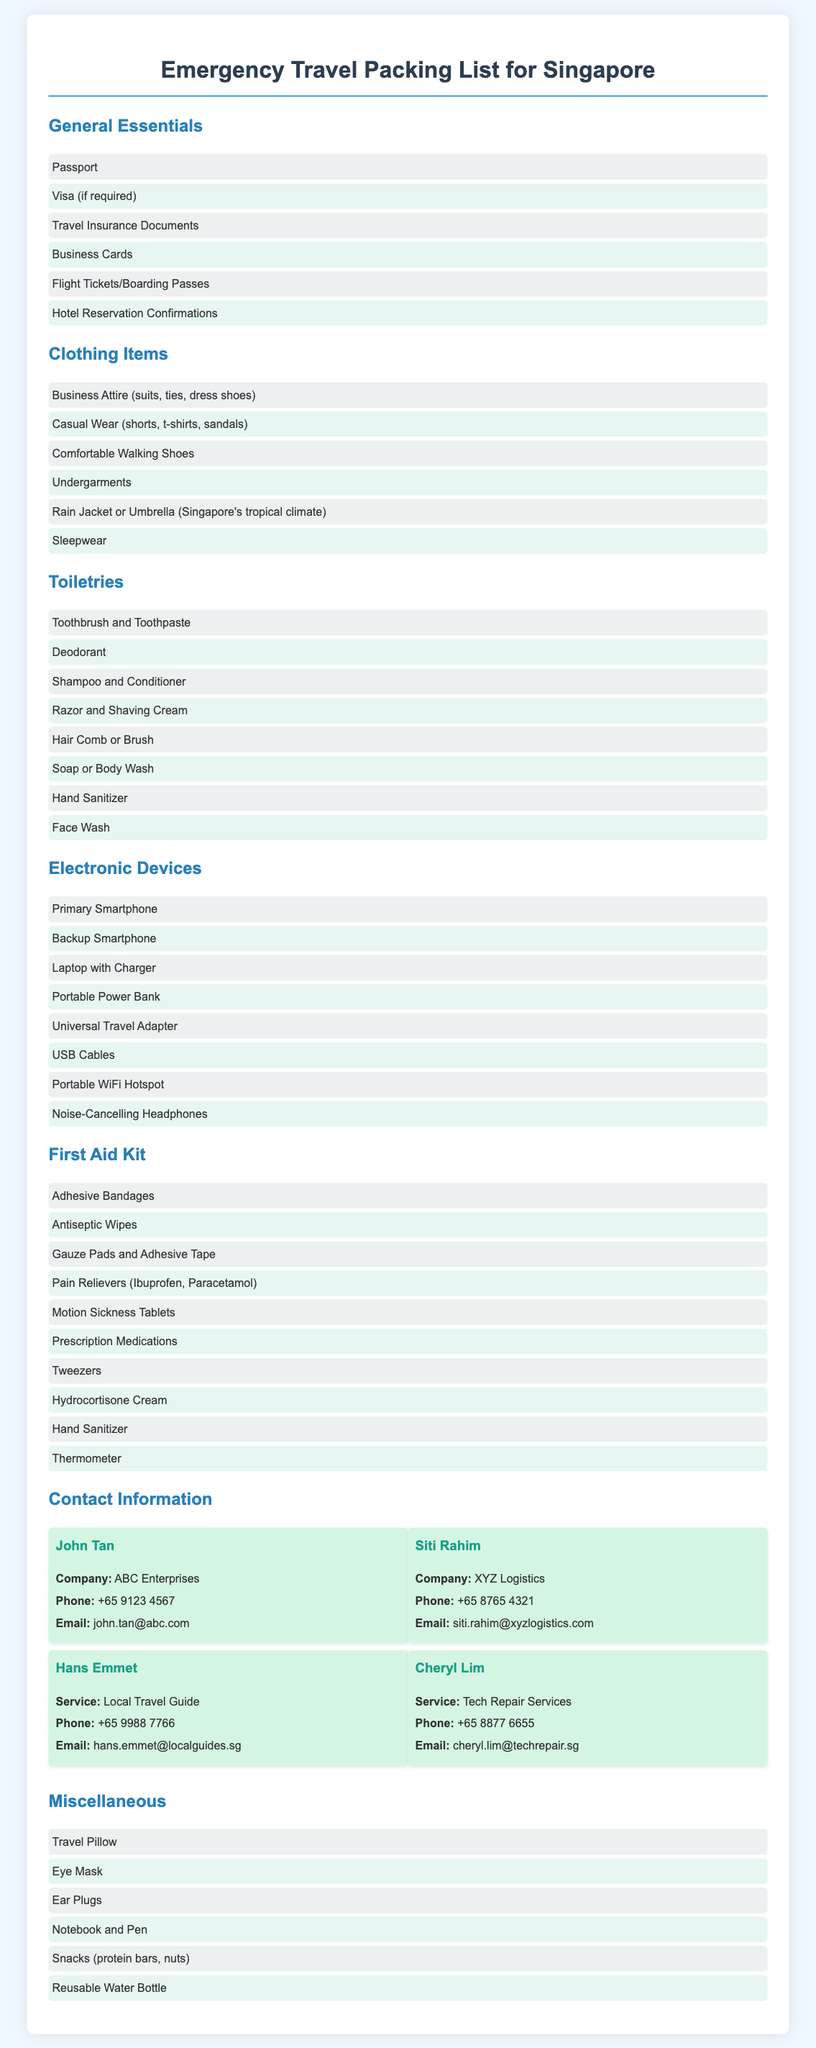what should I pack in my First Aid Kit? The document lists specific items that should be included in the First Aid Kit, such as Adhesive Bandages and Pain Relievers.
Answer: Adhesive Bandages, Antiseptic Wipes, Gauze Pads, Pain Relievers, Motion Sickness Tablets, Prescription Medications, Tweezers, Hydrocortisone Cream, Hand Sanitizer, Thermometer how many Contact Information entries are provided? The document contains four contact information entries for individuals and service providers.
Answer: 4 what type of clothing items should I bring? The document specifies various clothing categories including Business Attire and Casual Wear for the trip.
Answer: Business Attire, Casual Wear, Comfortable Walking Shoes, Undergarments, Rain Jacket, Sleepwear who is the contact for Local Travel Guide? The contact information includes a name associated with the service of a local travel guide.
Answer: Hans Emmet which electronic devices should I ensure to have? The list of electronic devices includes primary and backup devices, a laptop, and a portable power bank among others.
Answer: Primary Smartphone, Backup Smartphone, Laptop, Portable Power Bank, Universal Adapter, USB Cables, Portable WiFi Hotspot, Noise-Cancelling Headphones what essential documents do I need to carry? Essential documents such as Passport, Visa, and Travel Insurance Documents are highlighted as necessary.
Answer: Passport, Visa, Travel Insurance Documents, Business Cards, Flight Tickets, Hotel Reservations who can provide Tech Repair Services? The document provides the name and contact details of a service provider for tech repairs.
Answer: Cheryl Lim what is one miscellaneous item suggested? The document mentions various miscellaneous items that could be useful during travel.
Answer: Travel Pillow 